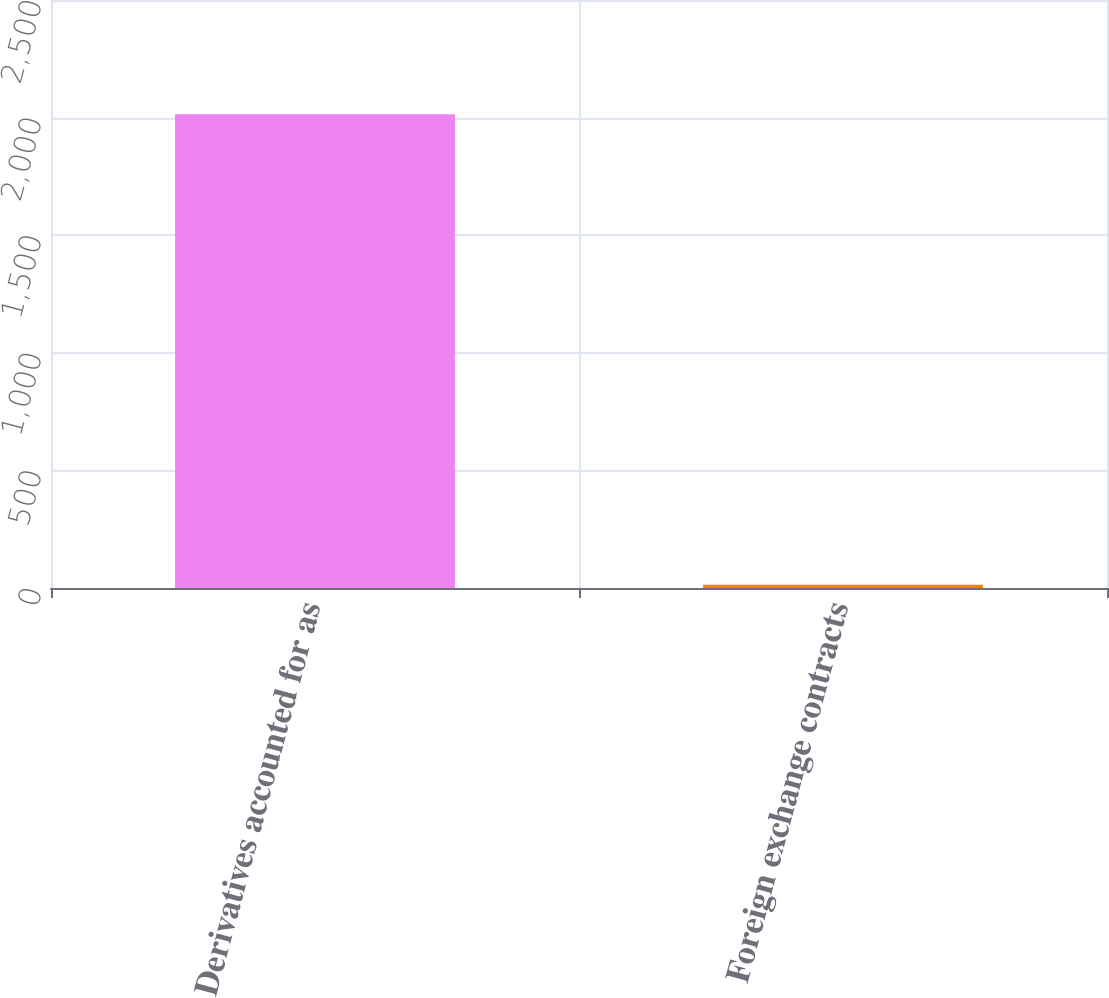<chart> <loc_0><loc_0><loc_500><loc_500><bar_chart><fcel>Derivatives accounted for as<fcel>Foreign exchange contracts<nl><fcel>2014<fcel>14<nl></chart> 